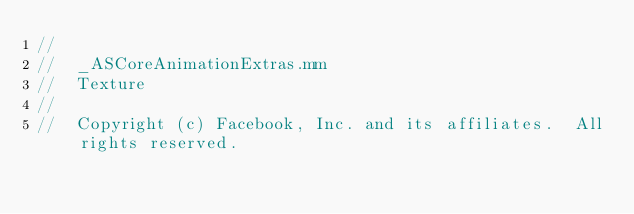Convert code to text. <code><loc_0><loc_0><loc_500><loc_500><_ObjectiveC_>//
//  _ASCoreAnimationExtras.mm
//  Texture
//
//  Copyright (c) Facebook, Inc. and its affiliates.  All rights reserved.</code> 